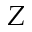Convert formula to latex. <formula><loc_0><loc_0><loc_500><loc_500>{ Z }</formula> 